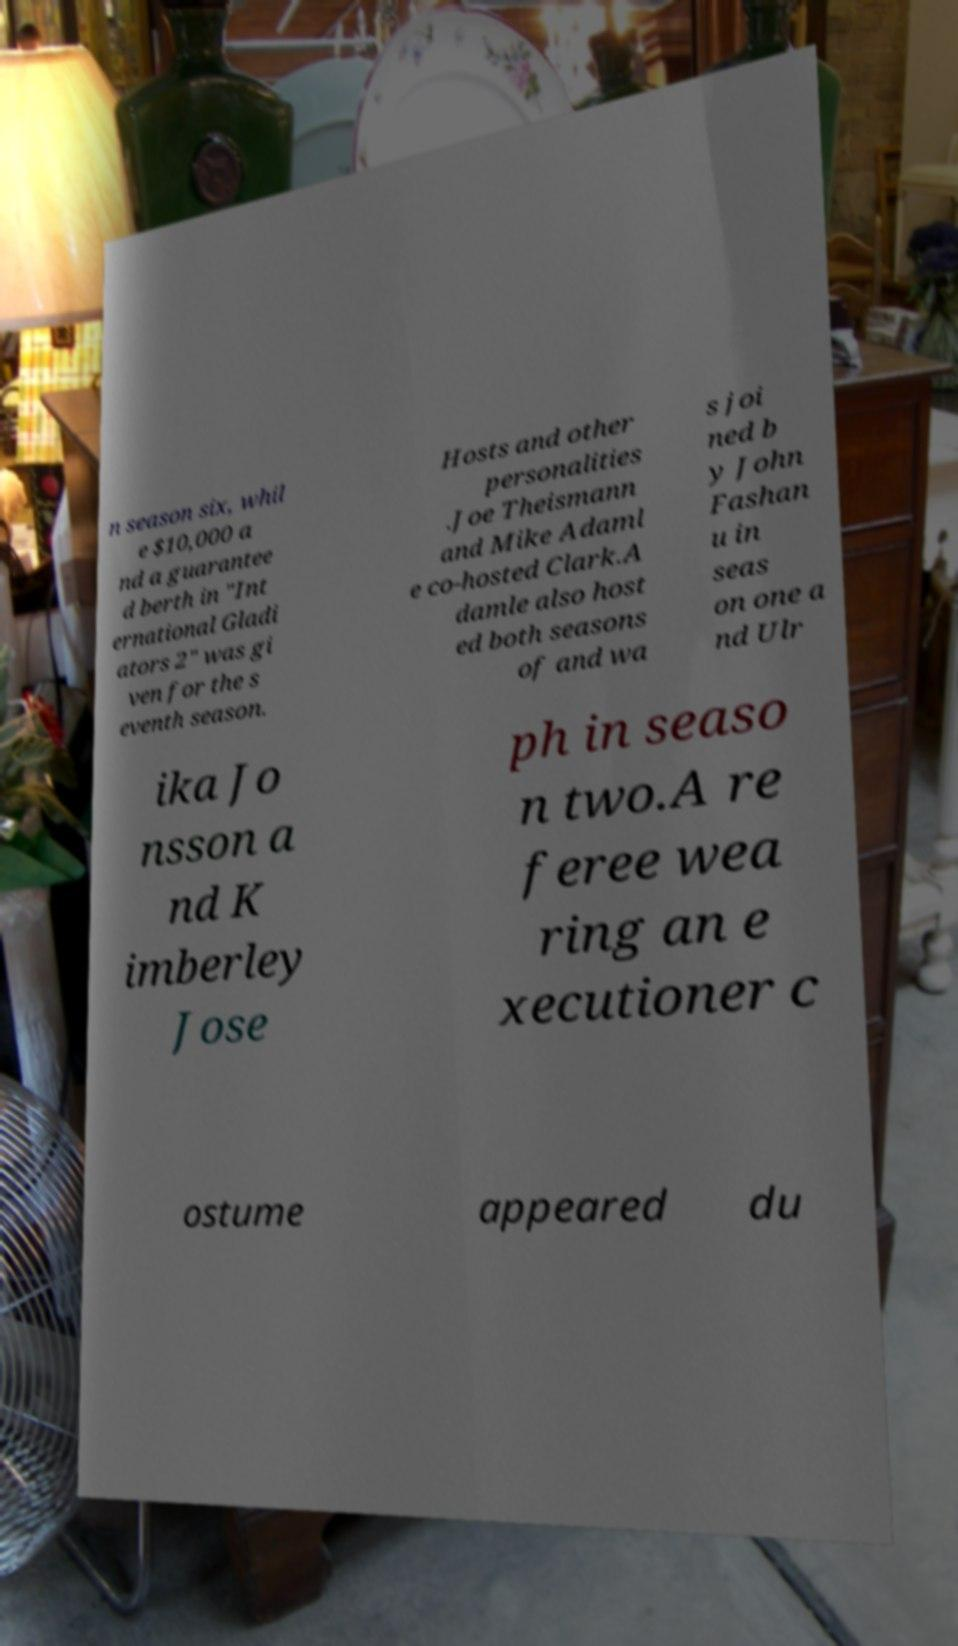Please identify and transcribe the text found in this image. n season six, whil e $10,000 a nd a guarantee d berth in "Int ernational Gladi ators 2" was gi ven for the s eventh season. Hosts and other personalities .Joe Theismann and Mike Adaml e co-hosted Clark.A damle also host ed both seasons of and wa s joi ned b y John Fashan u in seas on one a nd Ulr ika Jo nsson a nd K imberley Jose ph in seaso n two.A re feree wea ring an e xecutioner c ostume appeared du 